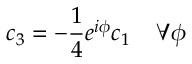<formula> <loc_0><loc_0><loc_500><loc_500>c _ { 3 } = - \frac { 1 } { 4 } e ^ { i \phi } c _ { 1 } \, \forall \phi</formula> 